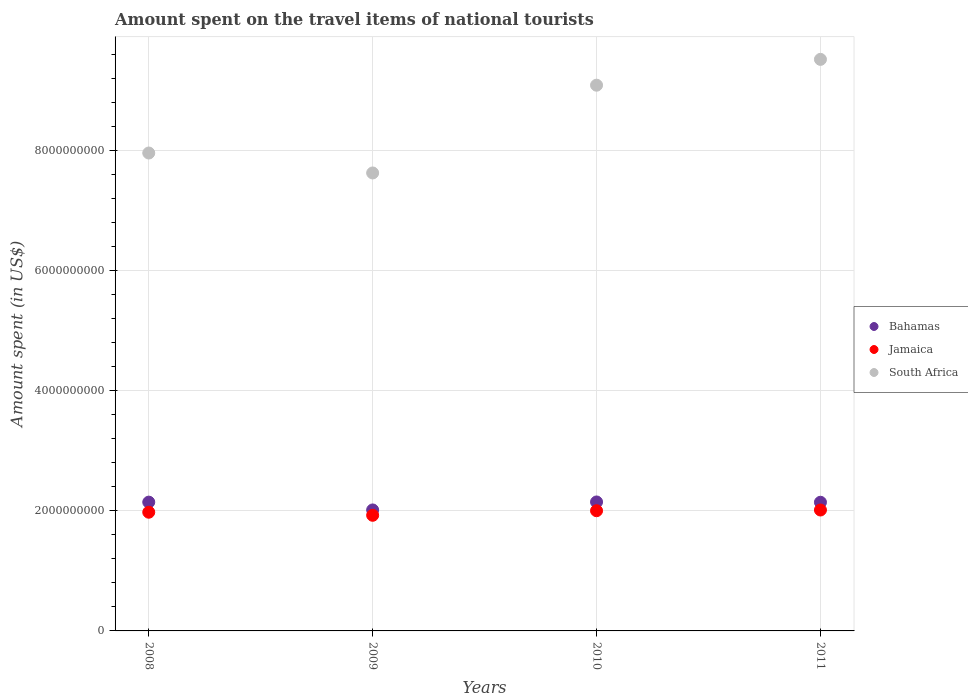Is the number of dotlines equal to the number of legend labels?
Your answer should be compact. Yes. What is the amount spent on the travel items of national tourists in Jamaica in 2011?
Keep it short and to the point. 2.01e+09. Across all years, what is the maximum amount spent on the travel items of national tourists in Jamaica?
Your answer should be very brief. 2.01e+09. Across all years, what is the minimum amount spent on the travel items of national tourists in Jamaica?
Give a very brief answer. 1.92e+09. What is the total amount spent on the travel items of national tourists in Bahamas in the graph?
Make the answer very short. 8.45e+09. What is the difference between the amount spent on the travel items of national tourists in Jamaica in 2008 and that in 2010?
Offer a very short reply. -2.50e+07. What is the difference between the amount spent on the travel items of national tourists in South Africa in 2009 and the amount spent on the travel items of national tourists in Bahamas in 2010?
Make the answer very short. 5.48e+09. What is the average amount spent on the travel items of national tourists in South Africa per year?
Keep it short and to the point. 8.54e+09. In the year 2011, what is the difference between the amount spent on the travel items of national tourists in Bahamas and amount spent on the travel items of national tourists in South Africa?
Give a very brief answer. -7.37e+09. In how many years, is the amount spent on the travel items of national tourists in Bahamas greater than 3600000000 US$?
Provide a short and direct response. 0. What is the ratio of the amount spent on the travel items of national tourists in Bahamas in 2009 to that in 2011?
Your answer should be very brief. 0.94. Is the amount spent on the travel items of national tourists in Bahamas in 2008 less than that in 2010?
Your answer should be compact. Yes. What is the difference between the highest and the second highest amount spent on the travel items of national tourists in South Africa?
Keep it short and to the point. 4.30e+08. What is the difference between the highest and the lowest amount spent on the travel items of national tourists in Jamaica?
Offer a very short reply. 8.80e+07. In how many years, is the amount spent on the travel items of national tourists in Bahamas greater than the average amount spent on the travel items of national tourists in Bahamas taken over all years?
Provide a succinct answer. 3. Is it the case that in every year, the sum of the amount spent on the travel items of national tourists in Jamaica and amount spent on the travel items of national tourists in South Africa  is greater than the amount spent on the travel items of national tourists in Bahamas?
Your answer should be compact. Yes. Does the amount spent on the travel items of national tourists in Jamaica monotonically increase over the years?
Ensure brevity in your answer.  No. Is the amount spent on the travel items of national tourists in Jamaica strictly greater than the amount spent on the travel items of national tourists in Bahamas over the years?
Offer a terse response. No. How many dotlines are there?
Your answer should be compact. 3. What is the difference between two consecutive major ticks on the Y-axis?
Offer a very short reply. 2.00e+09. Does the graph contain any zero values?
Offer a very short reply. No. Does the graph contain grids?
Provide a succinct answer. Yes. Where does the legend appear in the graph?
Ensure brevity in your answer.  Center right. How are the legend labels stacked?
Offer a terse response. Vertical. What is the title of the graph?
Offer a terse response. Amount spent on the travel items of national tourists. Does "Kosovo" appear as one of the legend labels in the graph?
Your answer should be very brief. No. What is the label or title of the X-axis?
Offer a very short reply. Years. What is the label or title of the Y-axis?
Provide a short and direct response. Amount spent (in US$). What is the Amount spent (in US$) in Bahamas in 2008?
Offer a very short reply. 2.14e+09. What is the Amount spent (in US$) in Jamaica in 2008?
Ensure brevity in your answer.  1.98e+09. What is the Amount spent (in US$) in South Africa in 2008?
Keep it short and to the point. 7.96e+09. What is the Amount spent (in US$) in Bahamas in 2009?
Keep it short and to the point. 2.01e+09. What is the Amount spent (in US$) in Jamaica in 2009?
Make the answer very short. 1.92e+09. What is the Amount spent (in US$) in South Africa in 2009?
Your answer should be compact. 7.62e+09. What is the Amount spent (in US$) of Bahamas in 2010?
Ensure brevity in your answer.  2.15e+09. What is the Amount spent (in US$) of Jamaica in 2010?
Give a very brief answer. 2.00e+09. What is the Amount spent (in US$) in South Africa in 2010?
Offer a very short reply. 9.08e+09. What is the Amount spent (in US$) of Bahamas in 2011?
Make the answer very short. 2.14e+09. What is the Amount spent (in US$) in Jamaica in 2011?
Provide a succinct answer. 2.01e+09. What is the Amount spent (in US$) of South Africa in 2011?
Your answer should be very brief. 9.52e+09. Across all years, what is the maximum Amount spent (in US$) in Bahamas?
Your response must be concise. 2.15e+09. Across all years, what is the maximum Amount spent (in US$) of Jamaica?
Ensure brevity in your answer.  2.01e+09. Across all years, what is the maximum Amount spent (in US$) in South Africa?
Your response must be concise. 9.52e+09. Across all years, what is the minimum Amount spent (in US$) in Bahamas?
Offer a very short reply. 2.01e+09. Across all years, what is the minimum Amount spent (in US$) of Jamaica?
Your response must be concise. 1.92e+09. Across all years, what is the minimum Amount spent (in US$) in South Africa?
Offer a terse response. 7.62e+09. What is the total Amount spent (in US$) of Bahamas in the graph?
Your answer should be compact. 8.45e+09. What is the total Amount spent (in US$) of Jamaica in the graph?
Offer a terse response. 7.92e+09. What is the total Amount spent (in US$) of South Africa in the graph?
Keep it short and to the point. 3.42e+1. What is the difference between the Amount spent (in US$) in Bahamas in 2008 and that in 2009?
Provide a short and direct response. 1.30e+08. What is the difference between the Amount spent (in US$) of Jamaica in 2008 and that in 2009?
Your answer should be compact. 5.10e+07. What is the difference between the Amount spent (in US$) of South Africa in 2008 and that in 2009?
Your answer should be very brief. 3.32e+08. What is the difference between the Amount spent (in US$) of Jamaica in 2008 and that in 2010?
Make the answer very short. -2.50e+07. What is the difference between the Amount spent (in US$) of South Africa in 2008 and that in 2010?
Ensure brevity in your answer.  -1.13e+09. What is the difference between the Amount spent (in US$) of Jamaica in 2008 and that in 2011?
Make the answer very short. -3.70e+07. What is the difference between the Amount spent (in US$) in South Africa in 2008 and that in 2011?
Keep it short and to the point. -1.56e+09. What is the difference between the Amount spent (in US$) of Bahamas in 2009 and that in 2010?
Ensure brevity in your answer.  -1.33e+08. What is the difference between the Amount spent (in US$) of Jamaica in 2009 and that in 2010?
Ensure brevity in your answer.  -7.60e+07. What is the difference between the Amount spent (in US$) of South Africa in 2009 and that in 2010?
Your response must be concise. -1.46e+09. What is the difference between the Amount spent (in US$) of Bahamas in 2009 and that in 2011?
Keep it short and to the point. -1.28e+08. What is the difference between the Amount spent (in US$) of Jamaica in 2009 and that in 2011?
Ensure brevity in your answer.  -8.80e+07. What is the difference between the Amount spent (in US$) in South Africa in 2009 and that in 2011?
Your answer should be very brief. -1.89e+09. What is the difference between the Amount spent (in US$) of Jamaica in 2010 and that in 2011?
Your response must be concise. -1.20e+07. What is the difference between the Amount spent (in US$) of South Africa in 2010 and that in 2011?
Give a very brief answer. -4.30e+08. What is the difference between the Amount spent (in US$) in Bahamas in 2008 and the Amount spent (in US$) in Jamaica in 2009?
Keep it short and to the point. 2.19e+08. What is the difference between the Amount spent (in US$) in Bahamas in 2008 and the Amount spent (in US$) in South Africa in 2009?
Provide a short and direct response. -5.48e+09. What is the difference between the Amount spent (in US$) of Jamaica in 2008 and the Amount spent (in US$) of South Africa in 2009?
Offer a terse response. -5.65e+09. What is the difference between the Amount spent (in US$) in Bahamas in 2008 and the Amount spent (in US$) in Jamaica in 2010?
Keep it short and to the point. 1.43e+08. What is the difference between the Amount spent (in US$) of Bahamas in 2008 and the Amount spent (in US$) of South Africa in 2010?
Offer a very short reply. -6.94e+09. What is the difference between the Amount spent (in US$) of Jamaica in 2008 and the Amount spent (in US$) of South Africa in 2010?
Provide a short and direct response. -7.11e+09. What is the difference between the Amount spent (in US$) in Bahamas in 2008 and the Amount spent (in US$) in Jamaica in 2011?
Your response must be concise. 1.31e+08. What is the difference between the Amount spent (in US$) in Bahamas in 2008 and the Amount spent (in US$) in South Africa in 2011?
Provide a short and direct response. -7.37e+09. What is the difference between the Amount spent (in US$) in Jamaica in 2008 and the Amount spent (in US$) in South Africa in 2011?
Provide a succinct answer. -7.54e+09. What is the difference between the Amount spent (in US$) of Bahamas in 2009 and the Amount spent (in US$) of Jamaica in 2010?
Offer a terse response. 1.30e+07. What is the difference between the Amount spent (in US$) in Bahamas in 2009 and the Amount spent (in US$) in South Africa in 2010?
Provide a succinct answer. -7.07e+09. What is the difference between the Amount spent (in US$) in Jamaica in 2009 and the Amount spent (in US$) in South Africa in 2010?
Your answer should be compact. -7.16e+09. What is the difference between the Amount spent (in US$) of Bahamas in 2009 and the Amount spent (in US$) of Jamaica in 2011?
Give a very brief answer. 1.00e+06. What is the difference between the Amount spent (in US$) of Bahamas in 2009 and the Amount spent (in US$) of South Africa in 2011?
Your response must be concise. -7.50e+09. What is the difference between the Amount spent (in US$) in Jamaica in 2009 and the Amount spent (in US$) in South Africa in 2011?
Keep it short and to the point. -7.59e+09. What is the difference between the Amount spent (in US$) of Bahamas in 2010 and the Amount spent (in US$) of Jamaica in 2011?
Your answer should be compact. 1.34e+08. What is the difference between the Amount spent (in US$) in Bahamas in 2010 and the Amount spent (in US$) in South Africa in 2011?
Offer a very short reply. -7.37e+09. What is the difference between the Amount spent (in US$) of Jamaica in 2010 and the Amount spent (in US$) of South Africa in 2011?
Keep it short and to the point. -7.51e+09. What is the average Amount spent (in US$) in Bahamas per year?
Your answer should be compact. 2.11e+09. What is the average Amount spent (in US$) of Jamaica per year?
Offer a very short reply. 1.98e+09. What is the average Amount spent (in US$) in South Africa per year?
Keep it short and to the point. 8.54e+09. In the year 2008, what is the difference between the Amount spent (in US$) of Bahamas and Amount spent (in US$) of Jamaica?
Your answer should be compact. 1.68e+08. In the year 2008, what is the difference between the Amount spent (in US$) of Bahamas and Amount spent (in US$) of South Africa?
Your answer should be very brief. -5.81e+09. In the year 2008, what is the difference between the Amount spent (in US$) of Jamaica and Amount spent (in US$) of South Africa?
Offer a terse response. -5.98e+09. In the year 2009, what is the difference between the Amount spent (in US$) in Bahamas and Amount spent (in US$) in Jamaica?
Give a very brief answer. 8.90e+07. In the year 2009, what is the difference between the Amount spent (in US$) in Bahamas and Amount spent (in US$) in South Africa?
Make the answer very short. -5.61e+09. In the year 2009, what is the difference between the Amount spent (in US$) of Jamaica and Amount spent (in US$) of South Africa?
Provide a short and direct response. -5.70e+09. In the year 2010, what is the difference between the Amount spent (in US$) of Bahamas and Amount spent (in US$) of Jamaica?
Your answer should be compact. 1.46e+08. In the year 2010, what is the difference between the Amount spent (in US$) in Bahamas and Amount spent (in US$) in South Africa?
Provide a short and direct response. -6.94e+09. In the year 2010, what is the difference between the Amount spent (in US$) in Jamaica and Amount spent (in US$) in South Africa?
Offer a very short reply. -7.08e+09. In the year 2011, what is the difference between the Amount spent (in US$) of Bahamas and Amount spent (in US$) of Jamaica?
Provide a succinct answer. 1.29e+08. In the year 2011, what is the difference between the Amount spent (in US$) of Bahamas and Amount spent (in US$) of South Africa?
Provide a succinct answer. -7.37e+09. In the year 2011, what is the difference between the Amount spent (in US$) in Jamaica and Amount spent (in US$) in South Africa?
Ensure brevity in your answer.  -7.50e+09. What is the ratio of the Amount spent (in US$) in Bahamas in 2008 to that in 2009?
Provide a short and direct response. 1.06. What is the ratio of the Amount spent (in US$) of Jamaica in 2008 to that in 2009?
Your response must be concise. 1.03. What is the ratio of the Amount spent (in US$) of South Africa in 2008 to that in 2009?
Your answer should be compact. 1.04. What is the ratio of the Amount spent (in US$) of Bahamas in 2008 to that in 2010?
Provide a short and direct response. 1. What is the ratio of the Amount spent (in US$) in Jamaica in 2008 to that in 2010?
Give a very brief answer. 0.99. What is the ratio of the Amount spent (in US$) in South Africa in 2008 to that in 2010?
Ensure brevity in your answer.  0.88. What is the ratio of the Amount spent (in US$) of Bahamas in 2008 to that in 2011?
Your answer should be very brief. 1. What is the ratio of the Amount spent (in US$) of Jamaica in 2008 to that in 2011?
Your response must be concise. 0.98. What is the ratio of the Amount spent (in US$) in South Africa in 2008 to that in 2011?
Your response must be concise. 0.84. What is the ratio of the Amount spent (in US$) in Bahamas in 2009 to that in 2010?
Give a very brief answer. 0.94. What is the ratio of the Amount spent (in US$) in Jamaica in 2009 to that in 2010?
Ensure brevity in your answer.  0.96. What is the ratio of the Amount spent (in US$) in South Africa in 2009 to that in 2010?
Provide a short and direct response. 0.84. What is the ratio of the Amount spent (in US$) of Bahamas in 2009 to that in 2011?
Your answer should be compact. 0.94. What is the ratio of the Amount spent (in US$) of Jamaica in 2009 to that in 2011?
Your answer should be compact. 0.96. What is the ratio of the Amount spent (in US$) of South Africa in 2009 to that in 2011?
Your answer should be compact. 0.8. What is the ratio of the Amount spent (in US$) in Bahamas in 2010 to that in 2011?
Provide a succinct answer. 1. What is the ratio of the Amount spent (in US$) in South Africa in 2010 to that in 2011?
Your answer should be compact. 0.95. What is the difference between the highest and the second highest Amount spent (in US$) of Bahamas?
Your response must be concise. 3.00e+06. What is the difference between the highest and the second highest Amount spent (in US$) in South Africa?
Keep it short and to the point. 4.30e+08. What is the difference between the highest and the lowest Amount spent (in US$) of Bahamas?
Provide a short and direct response. 1.33e+08. What is the difference between the highest and the lowest Amount spent (in US$) in Jamaica?
Your answer should be compact. 8.80e+07. What is the difference between the highest and the lowest Amount spent (in US$) of South Africa?
Offer a terse response. 1.89e+09. 